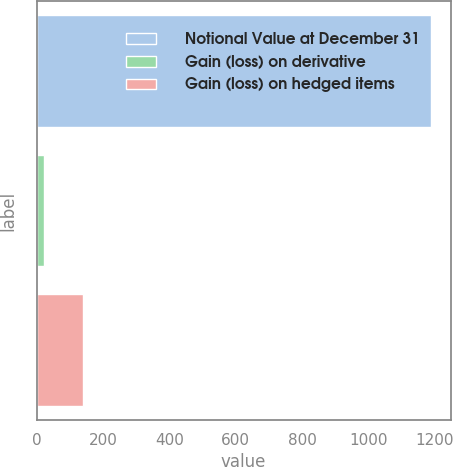<chart> <loc_0><loc_0><loc_500><loc_500><bar_chart><fcel>Notional Value at December 31<fcel>Gain (loss) on derivative<fcel>Gain (loss) on hedged items<nl><fcel>1188<fcel>22<fcel>138.6<nl></chart> 